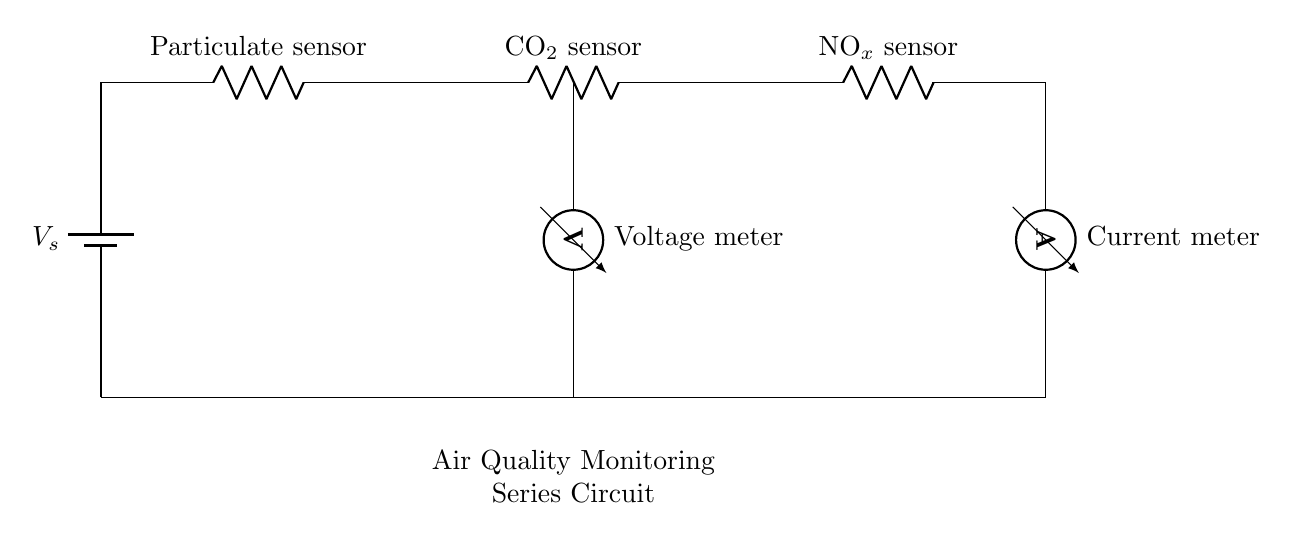What is the total number of sensors in this circuit? The circuit diagram shows three sensors: a particulate sensor, a CO2 sensor, and a NOx sensor.
Answer: Three What type of circuit is represented in this diagram? The diagram depicts a series circuit, where all the components are connected in a single path for current flow.
Answer: Series What is the purpose of the current meter? The current meter in the circuit measures the flow of current through all components in series, providing insight into overall circuit behavior.
Answer: Measure current Which component measures voltage in this circuit? The voltage meter, positioned in the circuit, specifically measures the voltage drop across the associated components, helping evaluate their functioning.
Answer: Voltage meter What is the role of the battery in this circuit? The battery serves as the power source, providing the necessary voltage for the circuit to operate and allowing current to flow through the sensors.
Answer: Power source If one sensor fails, what happens to the other sensors in this series circuit? In a series circuit, all components are dependent on each other; if one sensor fails, it will interrupt the current flow, causing all other sensors to also stop working.
Answer: Current stops How does the arrangement of the sensors affect the overall resistance of the circuit? In a series circuit, the total resistance is the sum of all individual resistances. Hence, adding more sensors increases the total resistance, affecting current flow as per Ohm's law.
Answer: Increases total resistance 